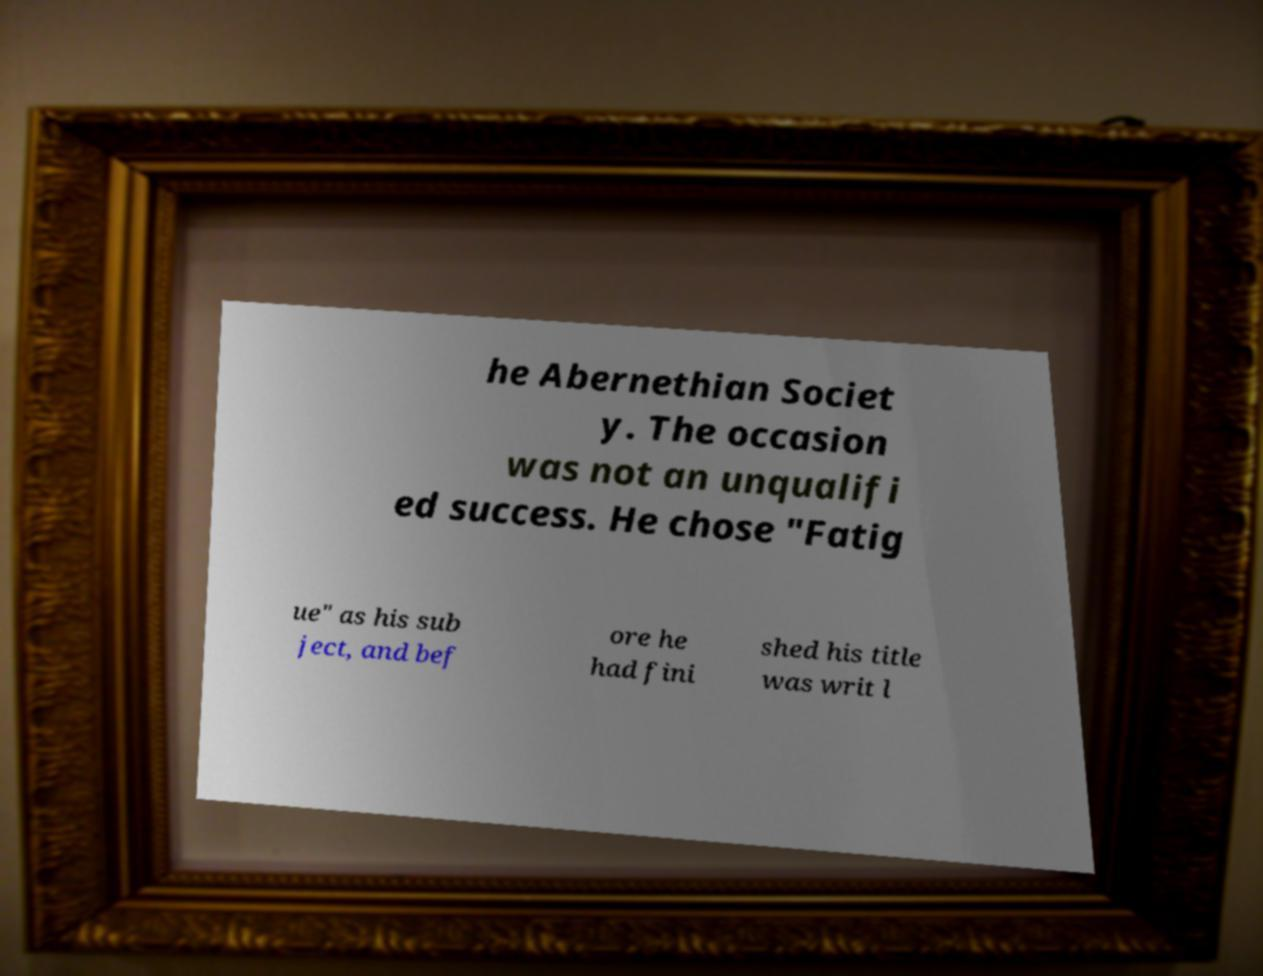For documentation purposes, I need the text within this image transcribed. Could you provide that? he Abernethian Societ y. The occasion was not an unqualifi ed success. He chose "Fatig ue" as his sub ject, and bef ore he had fini shed his title was writ l 